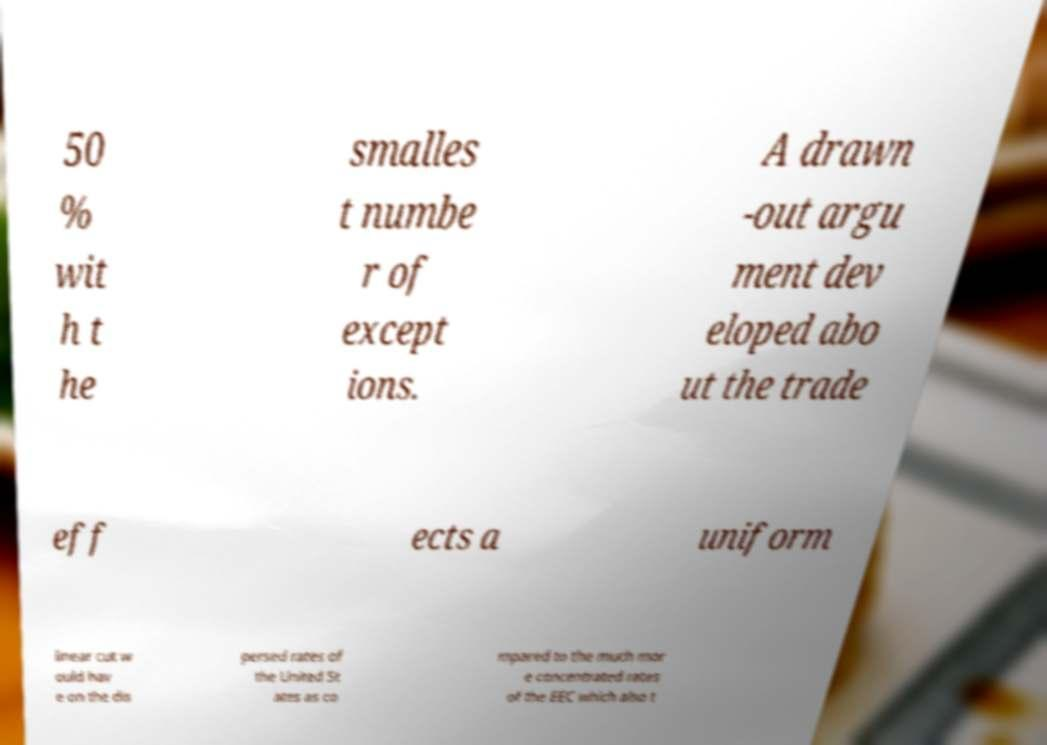For documentation purposes, I need the text within this image transcribed. Could you provide that? 50 % wit h t he smalles t numbe r of except ions. A drawn -out argu ment dev eloped abo ut the trade eff ects a uniform linear cut w ould hav e on the dis persed rates of the United St ates as co mpared to the much mor e concentrated rates of the EEC which also t 